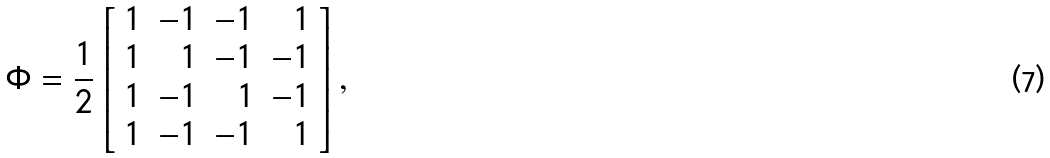<formula> <loc_0><loc_0><loc_500><loc_500>\Phi = \frac { 1 } { 2 } \left [ \begin{array} { r r r r } 1 & - 1 & - 1 & 1 \\ 1 & 1 & - 1 & - 1 \\ 1 & - 1 & 1 & - 1 \\ 1 & - 1 & - 1 & 1 \end{array} \right ] ,</formula> 